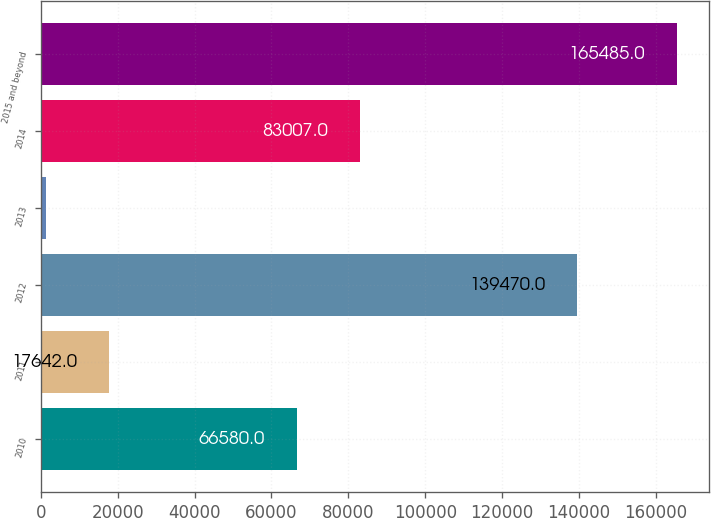Convert chart to OTSL. <chart><loc_0><loc_0><loc_500><loc_500><bar_chart><fcel>2010<fcel>2011<fcel>2012<fcel>2013<fcel>2014<fcel>2015 and beyond<nl><fcel>66580<fcel>17642<fcel>139470<fcel>1215<fcel>83007<fcel>165485<nl></chart> 